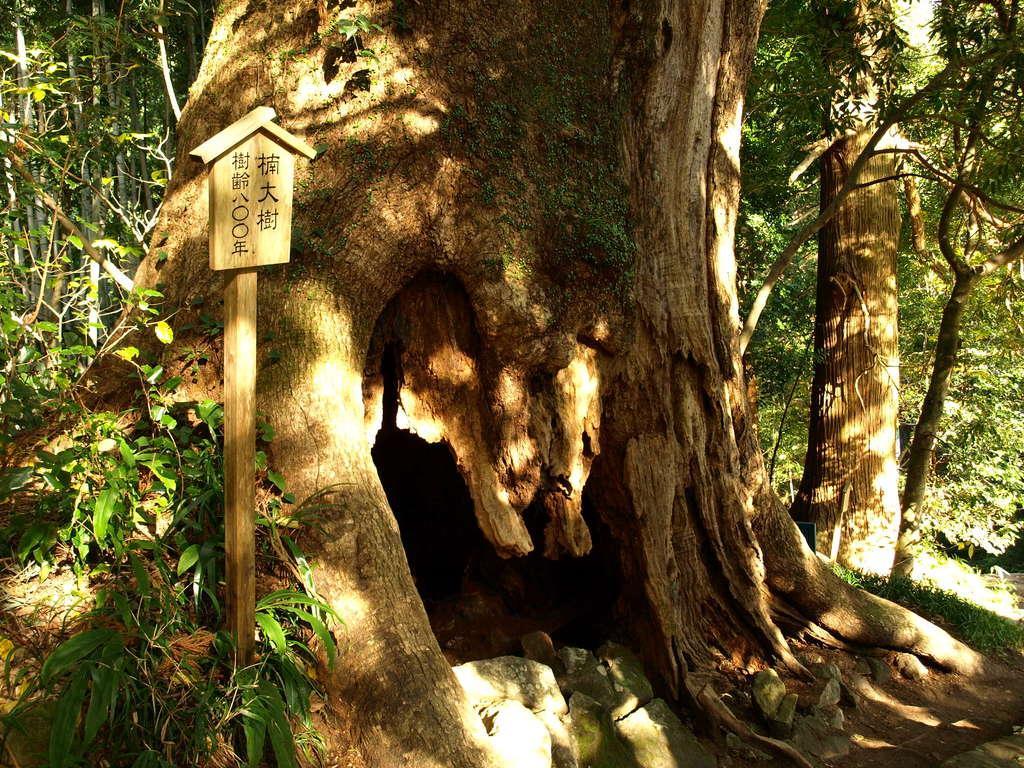Please provide a concise description of this image. In this image we can see a board with some text is placed on the pole. In the background we can see a group of trees. 